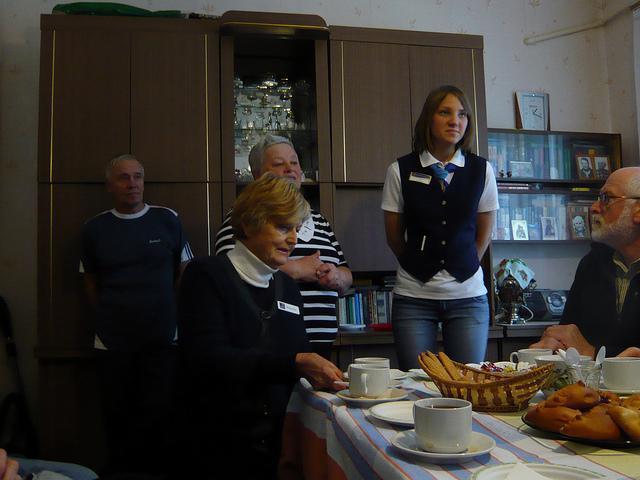How many people are in this picture?
Give a very brief answer. 5. How many people in the photo?
Give a very brief answer. 5. How many serving bowls/dishes are on the counter?
Give a very brief answer. 2. How many people have their glasses on?
Give a very brief answer. 1. How many people in this picture are women?
Give a very brief answer. 3. How many people are there?
Give a very brief answer. 5. 